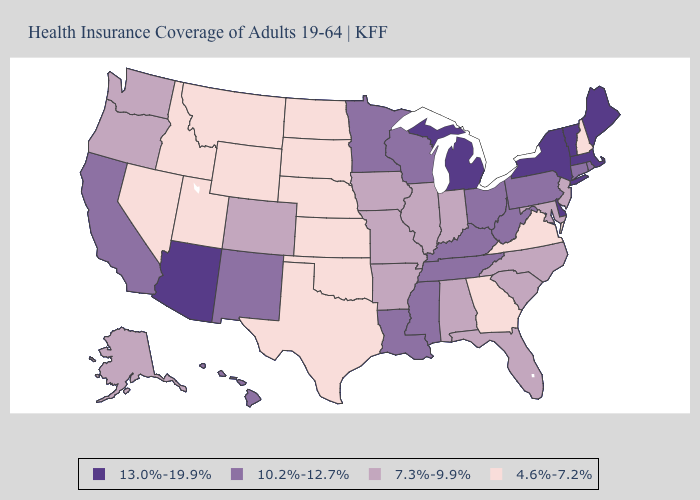What is the highest value in the South ?
Concise answer only. 13.0%-19.9%. Name the states that have a value in the range 4.6%-7.2%?
Quick response, please. Georgia, Idaho, Kansas, Montana, Nebraska, Nevada, New Hampshire, North Dakota, Oklahoma, South Dakota, Texas, Utah, Virginia, Wyoming. Does the map have missing data?
Answer briefly. No. Does the map have missing data?
Write a very short answer. No. What is the highest value in states that border North Carolina?
Answer briefly. 10.2%-12.7%. Does Nevada have the highest value in the USA?
Keep it brief. No. Does Maine have the highest value in the USA?
Quick response, please. Yes. Among the states that border Indiana , which have the lowest value?
Concise answer only. Illinois. What is the value of Maine?
Short answer required. 13.0%-19.9%. Does Alaska have the lowest value in the West?
Answer briefly. No. What is the value of Pennsylvania?
Be succinct. 10.2%-12.7%. What is the value of Iowa?
Short answer required. 7.3%-9.9%. Which states have the highest value in the USA?
Write a very short answer. Arizona, Delaware, Maine, Massachusetts, Michigan, New York, Vermont. Which states have the lowest value in the Northeast?
Answer briefly. New Hampshire. What is the value of New York?
Concise answer only. 13.0%-19.9%. 